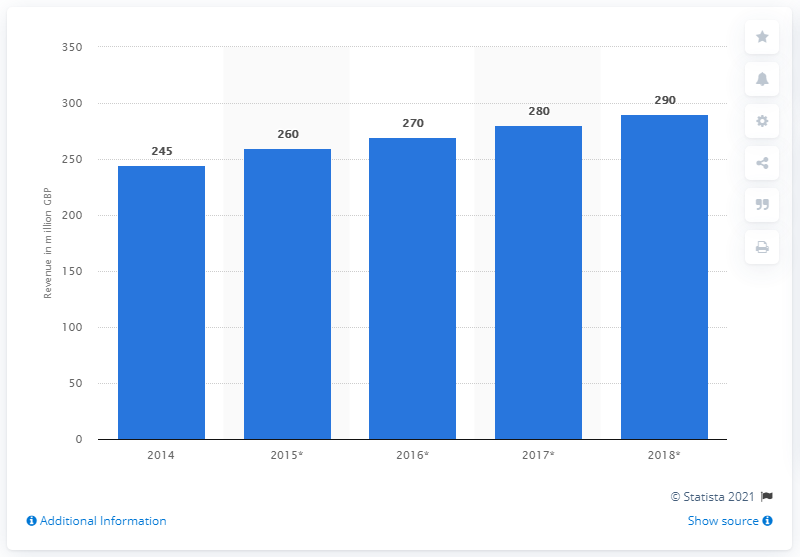What does the asterisk next to the years 2015 to 2018 indicate? The asterisk next to the years 2015 to 2018 suggests there could be additional information or footnotes related to the data for these years. It usually implies that there is more to the numbers than what is presented, such as estimates or re-stated figures. 